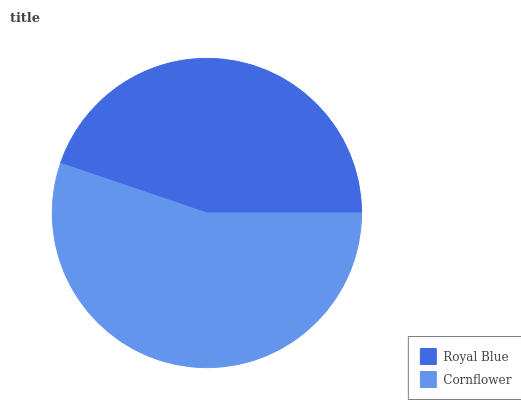Is Royal Blue the minimum?
Answer yes or no. Yes. Is Cornflower the maximum?
Answer yes or no. Yes. Is Cornflower the minimum?
Answer yes or no. No. Is Cornflower greater than Royal Blue?
Answer yes or no. Yes. Is Royal Blue less than Cornflower?
Answer yes or no. Yes. Is Royal Blue greater than Cornflower?
Answer yes or no. No. Is Cornflower less than Royal Blue?
Answer yes or no. No. Is Cornflower the high median?
Answer yes or no. Yes. Is Royal Blue the low median?
Answer yes or no. Yes. Is Royal Blue the high median?
Answer yes or no. No. Is Cornflower the low median?
Answer yes or no. No. 